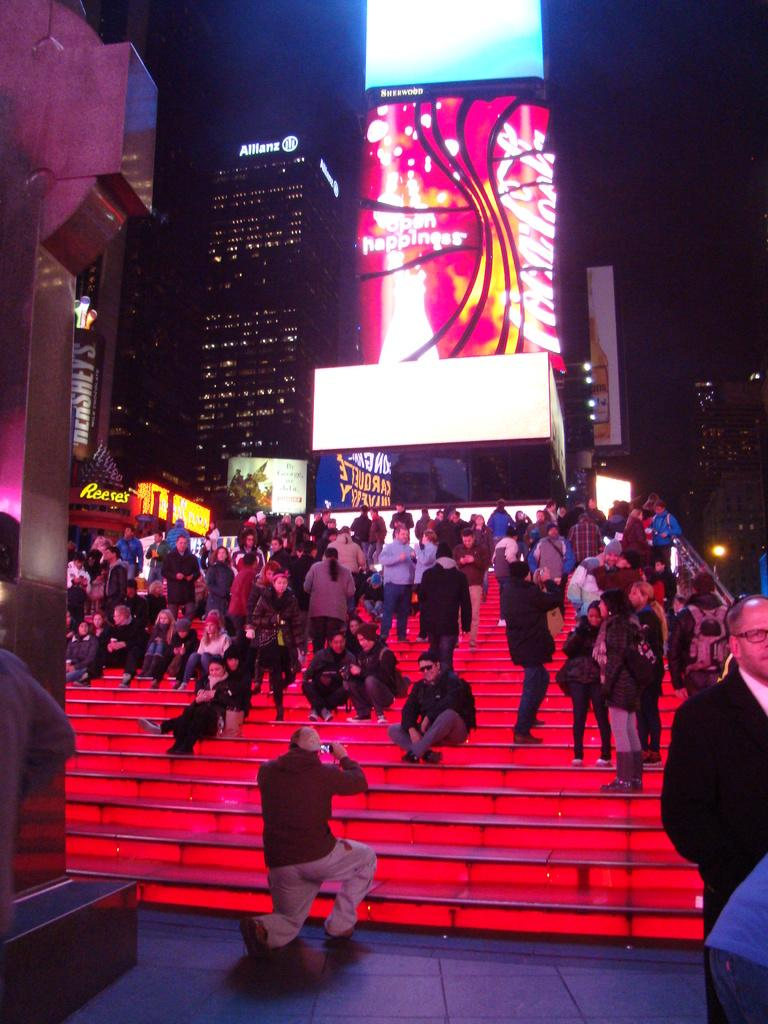What is the main subject in the foreground of the image? There is a crowd in the foreground of the image. Where is the crowd located? The crowd is on a staircase. What can be seen in the background of the image? There are buildings, a screen, and lights visible in the background. What time of day was the image taken? The image was taken during nighttime. How many loaves of bread can be seen on the veil of the ladybug in the image? There are no loaves of bread, veils, or ladybugs present in the image. 